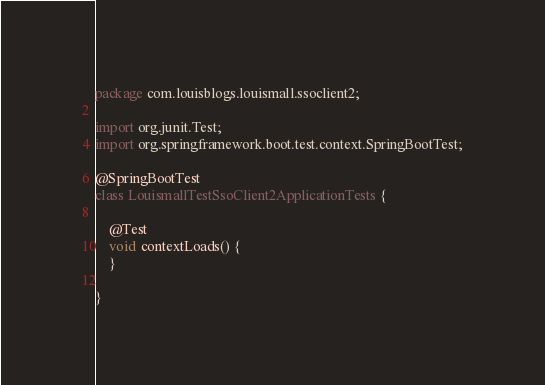Convert code to text. <code><loc_0><loc_0><loc_500><loc_500><_Java_>package com.louisblogs.louismall.ssoclient2;

import org.junit.Test;
import org.springframework.boot.test.context.SpringBootTest;

@SpringBootTest
class LouismallTestSsoClient2ApplicationTests {

	@Test
	void contextLoads() {
	}

}
</code> 